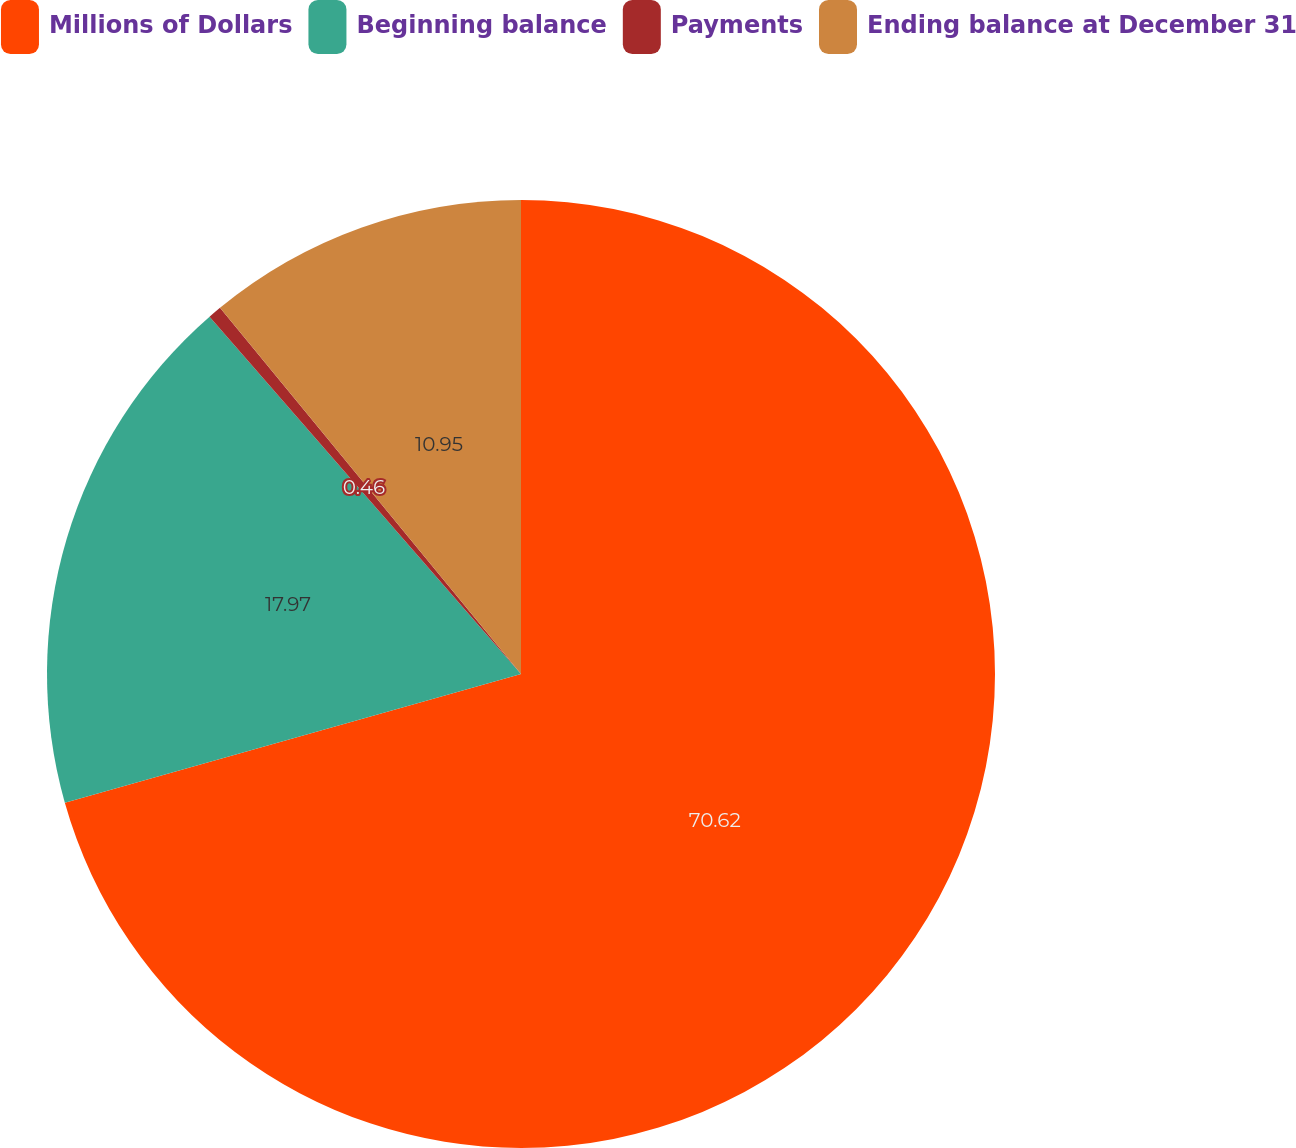<chart> <loc_0><loc_0><loc_500><loc_500><pie_chart><fcel>Millions of Dollars<fcel>Beginning balance<fcel>Payments<fcel>Ending balance at December 31<nl><fcel>70.62%<fcel>17.97%<fcel>0.46%<fcel>10.95%<nl></chart> 